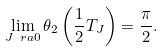Convert formula to latex. <formula><loc_0><loc_0><loc_500><loc_500>\lim _ { J \ r a 0 } \theta _ { 2 } \left ( \frac { 1 } { 2 } T _ { J } \right ) = \frac { \pi } { 2 } .</formula> 